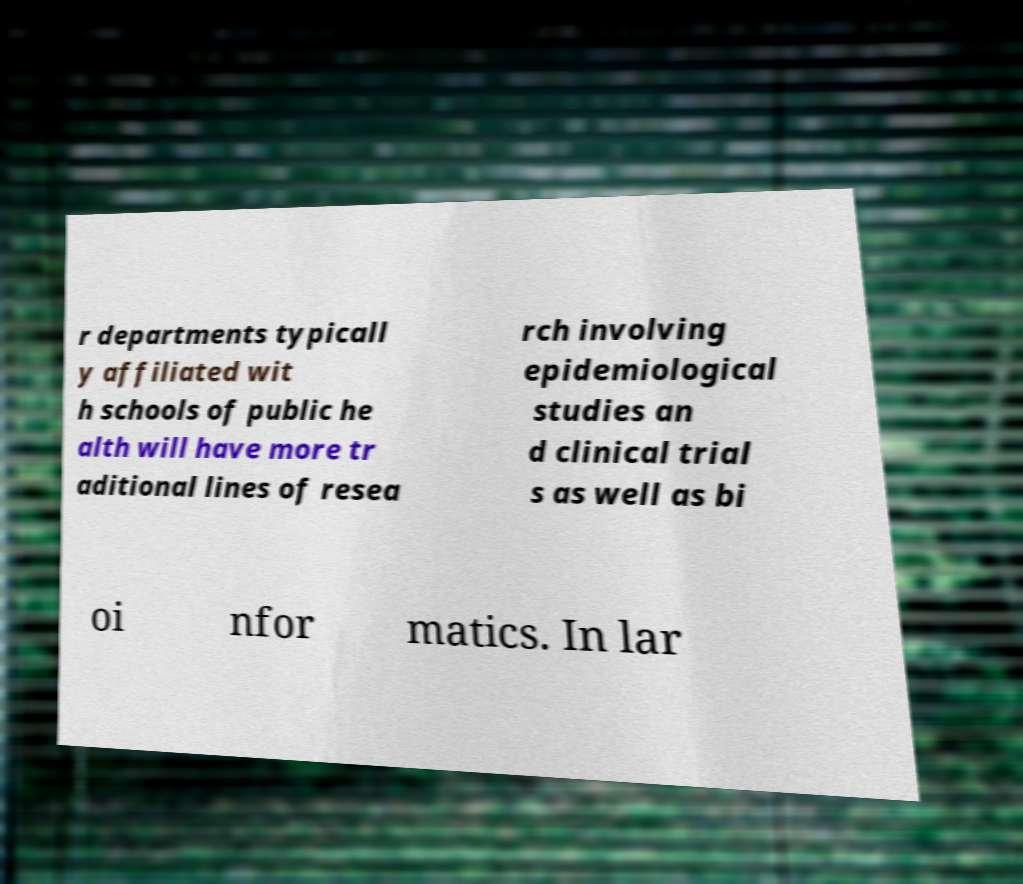What messages or text are displayed in this image? I need them in a readable, typed format. r departments typicall y affiliated wit h schools of public he alth will have more tr aditional lines of resea rch involving epidemiological studies an d clinical trial s as well as bi oi nfor matics. In lar 